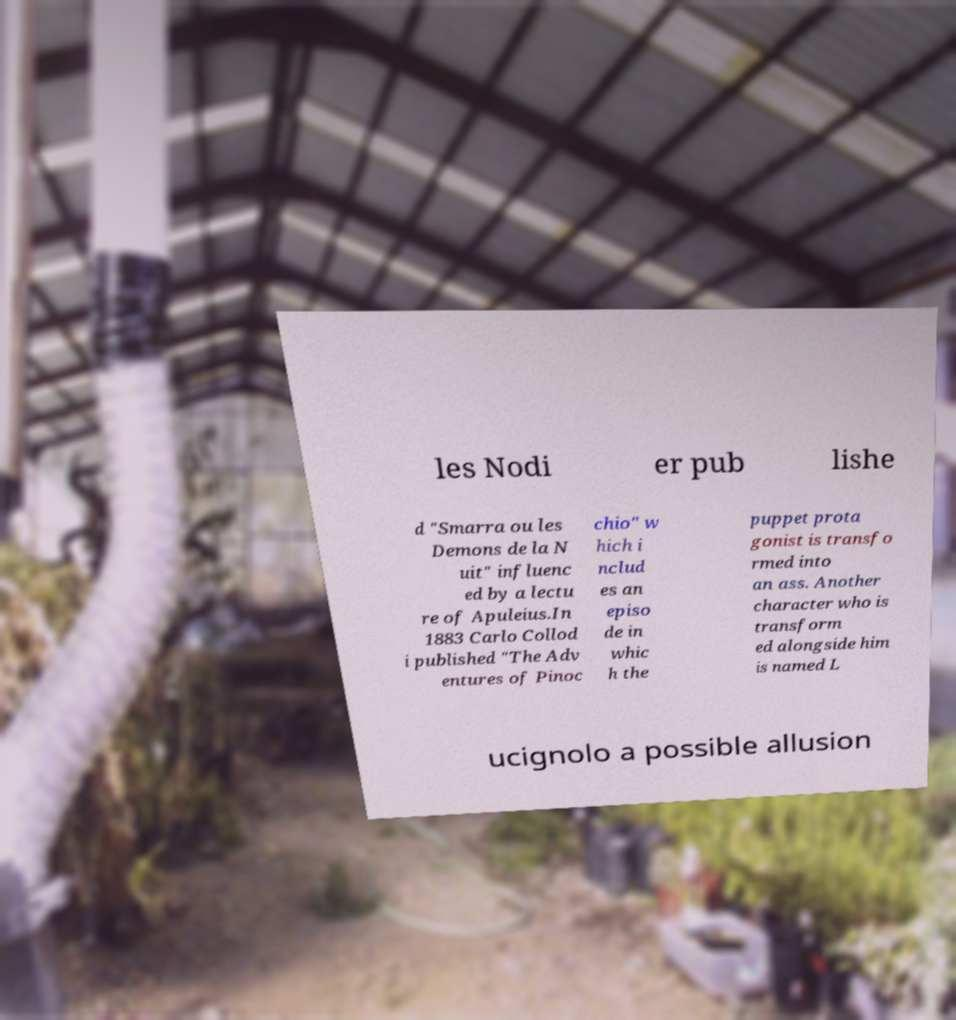Please read and relay the text visible in this image. What does it say? les Nodi er pub lishe d "Smarra ou les Demons de la N uit" influenc ed by a lectu re of Apuleius.In 1883 Carlo Collod i published "The Adv entures of Pinoc chio" w hich i nclud es an episo de in whic h the puppet prota gonist is transfo rmed into an ass. Another character who is transform ed alongside him is named L ucignolo a possible allusion 